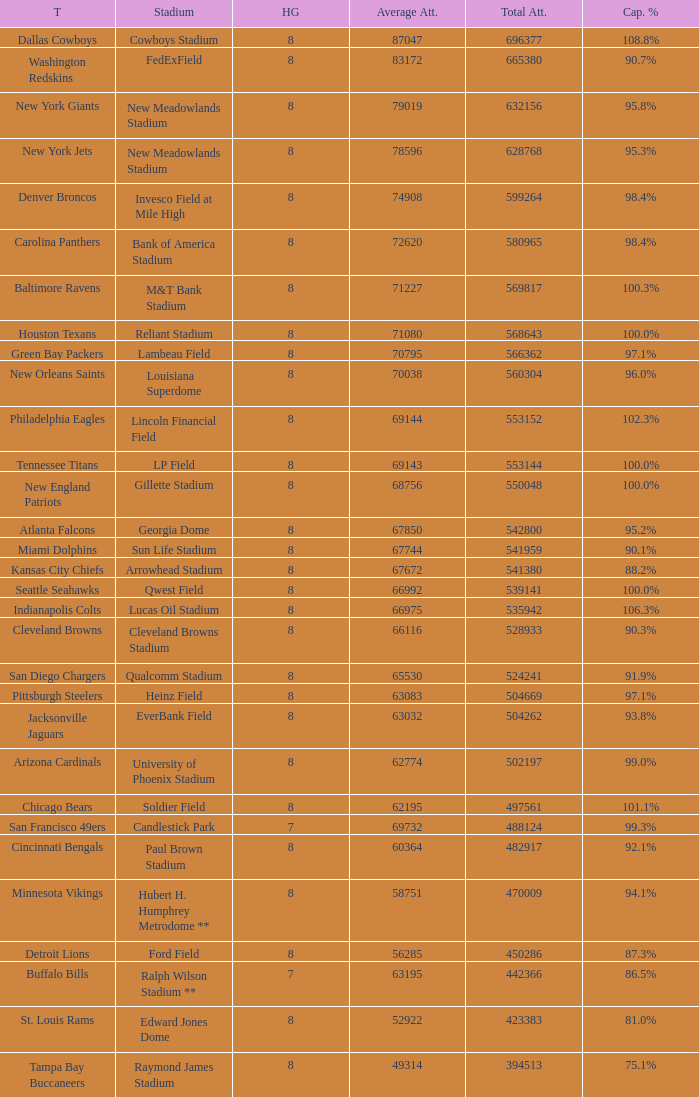What was average attendance when total attendance was 541380? 67672.0. 